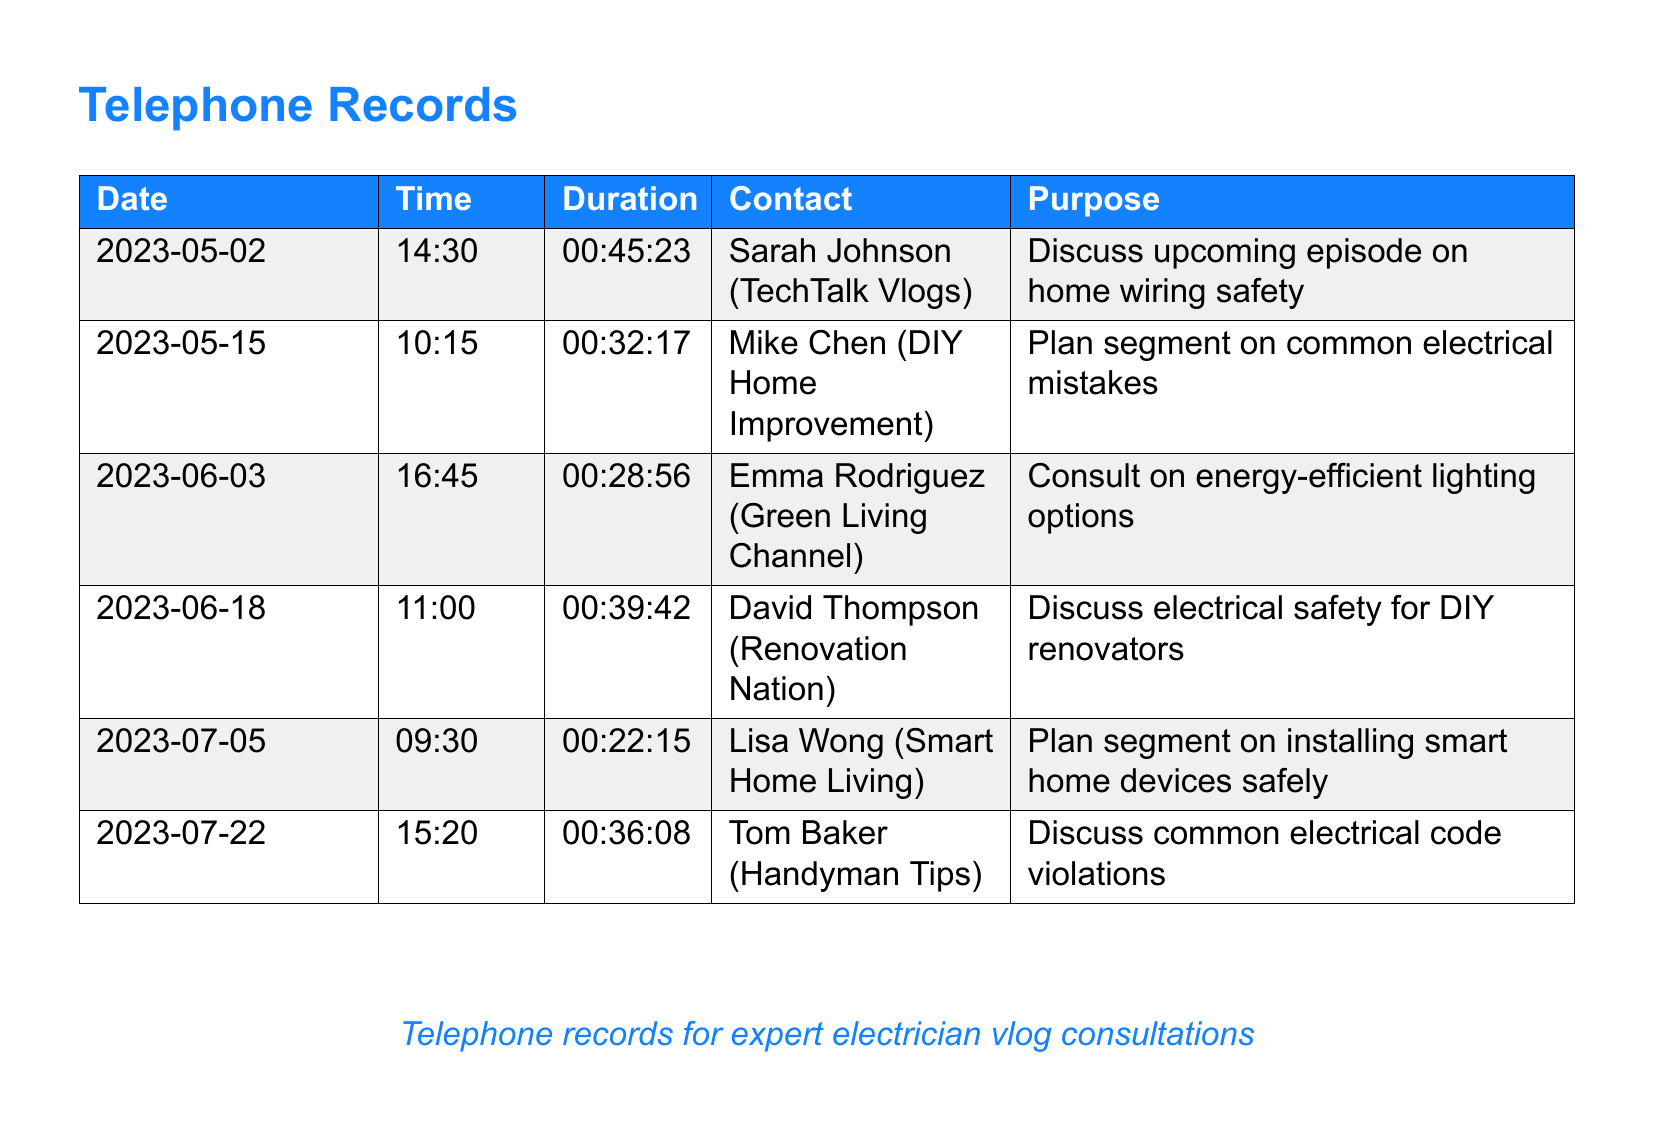What date was the consultation with Sarah Johnson? The date is found in the first row of the document, which lists the call with Sarah Johnson on May 2, 2023.
Answer: 2023-05-02 How long was the call with Mike Chen? The duration of the call with Mike Chen is indicated in the document as 32 minutes and 17 seconds.
Answer: 00:32:17 What was the purpose of the call on June 18? The purpose of the call can be found in the row for the call dated June 18, which is about electrical safety for DIY renovators.
Answer: Discuss electrical safety for DIY renovators Who was consulted on energy-efficient lighting? The name of the contact for the consultation on energy-efficient lighting is stated in the row for June 3, which includes Emma Rodriguez.
Answer: Emma Rodriguez How many total consultations are listed in the document? The total number of consultations is determined by counting the rows in the document, which include six entries.
Answer: 6 Which contact discussed common electrical mistakes? The document specifies that Mike Chen discussed common electrical mistakes in his consultation.
Answer: Mike Chen What is the earliest date noted in the call log? The earliest date is found by looking at the first row of the log, which shows the first consultation on May 2, 2023.
Answer: 2023-05-02 What was the common theme discussed in the July 22 call? The theme for the call on July 22 is common electrical code violations as stated in the document.
Answer: Common electrical code violations What time was the consultation with Tom Baker? The time of the consultation with Tom Baker is recorded as 15:20 on July 22 in the document.
Answer: 15:20 